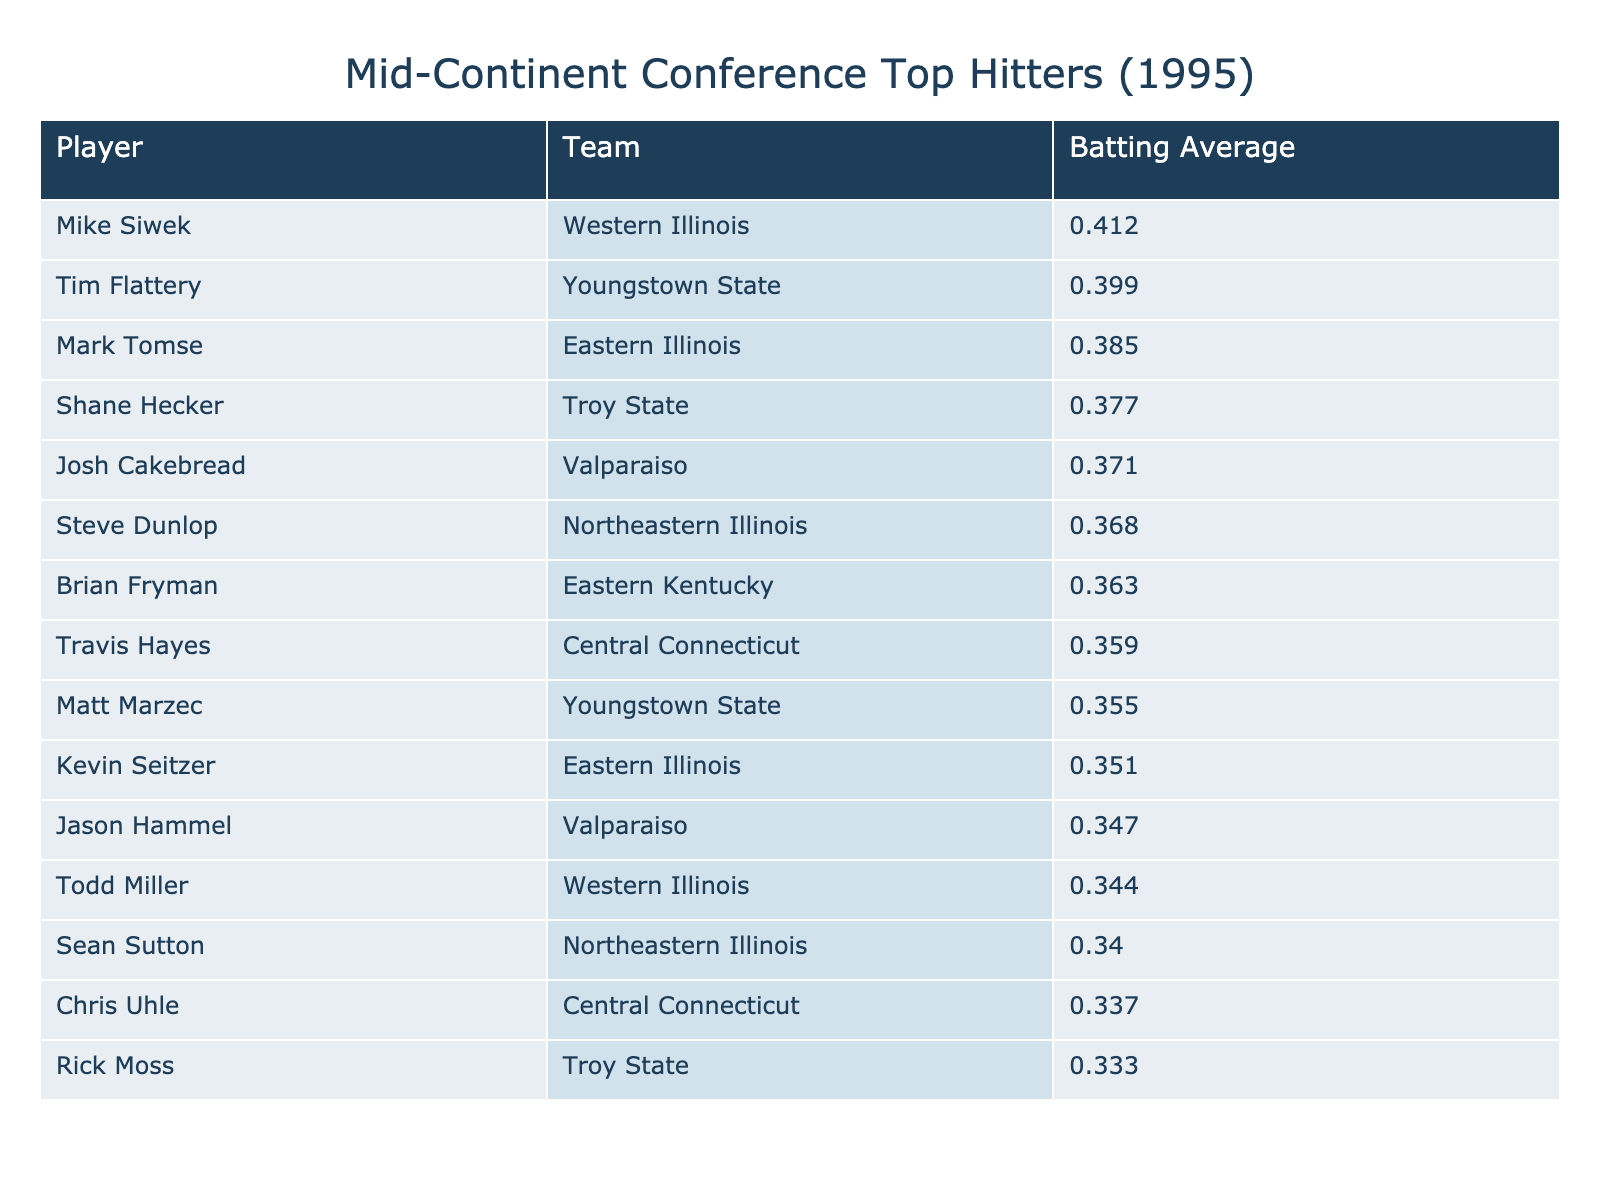What is the highest batting average in the table? The highest batting average can be found in the "Batting Average" column. Scanning the values, the maximum is 0.412, associated with Mike Siwek from Western Illinois.
Answer: 0.412 Which player has the lowest batting average in the table? The lowest batting average can be identified by looking through the "Batting Average" column for the smallest value. The value is 0.333 for Rick Moss from Troy State.
Answer: 0.333 How many players have a batting average above 0.370? To find this, count the number of batting averages that are greater than 0.370. There are 6 players above this threshold: Mike Siwek, Tim Flattery, Mark Tomse, Shane Hecker, Josh Cakebread, and Steve Dunlop.
Answer: 6 What is the average batting average of the players featured? To calculate the average, first sum all the batting averages: 0.412 + 0.399 + 0.385 + 0.377 + 0.371 + 0.368 + 0.363 + 0.359 + 0.355 + 0.351 + 0.347 + 0.344 + 0.340 + 0.337 + 0.333 = 5.36. Next, divide by the total number of players, which is 15: 5.36 / 15 = 0.3573.
Answer: 0.3573 Is there a player from Eastern Illinois with a batting average above 0.360? Looking at the "Team" column for Eastern Illinois, the players listed are Mark Tomse (0.385) and Kevin Seitzer (0.351). Since Mark Tomse has a batting average above 0.360, the answer is yes.
Answer: Yes What is the difference between the highest and lowest batting averages? First, identify the highest batting average (0.412 for Mike Siwek) and the lowest (0.333 for Rick Moss). The difference is calculated as 0.412 - 0.333 = 0.079.
Answer: 0.079 How many players are from Youngstown State and what are their batting averages? From the table, there are 2 players from Youngstown State: Tim Flattery (0.399) and Matt Marzec (0.355). Therefore, the count is 2 and their averages are 0.399 and 0.355.
Answer: 2 players: 0.399, 0.355 Which team has the player with the second-highest batting average? The second-highest batting average is 0.399, which belongs to Tim Flattery from Youngstown State. Hence, the team is identified as Youngstown State.
Answer: Youngstown State If you combine the batting averages of the two highest players, what is the total? The two highest batting averages belong to Mike Siwek (0.412) and Tim Flattery (0.399). Adding these, we get 0.412 + 0.399 = 0.811.
Answer: 0.811 What percentage of players have batting averages below 0.350? First, count the players below 0.350. This includes Jason Hammel (0.347), Todd Miller (0.344), Sean Sutton (0.340), Chris Uhle (0.337), and Rick Moss (0.333), totaling 5 players. Since there are 15 players overall, the percentage is (5/15) * 100 = 33.33%.
Answer: 33.33% 